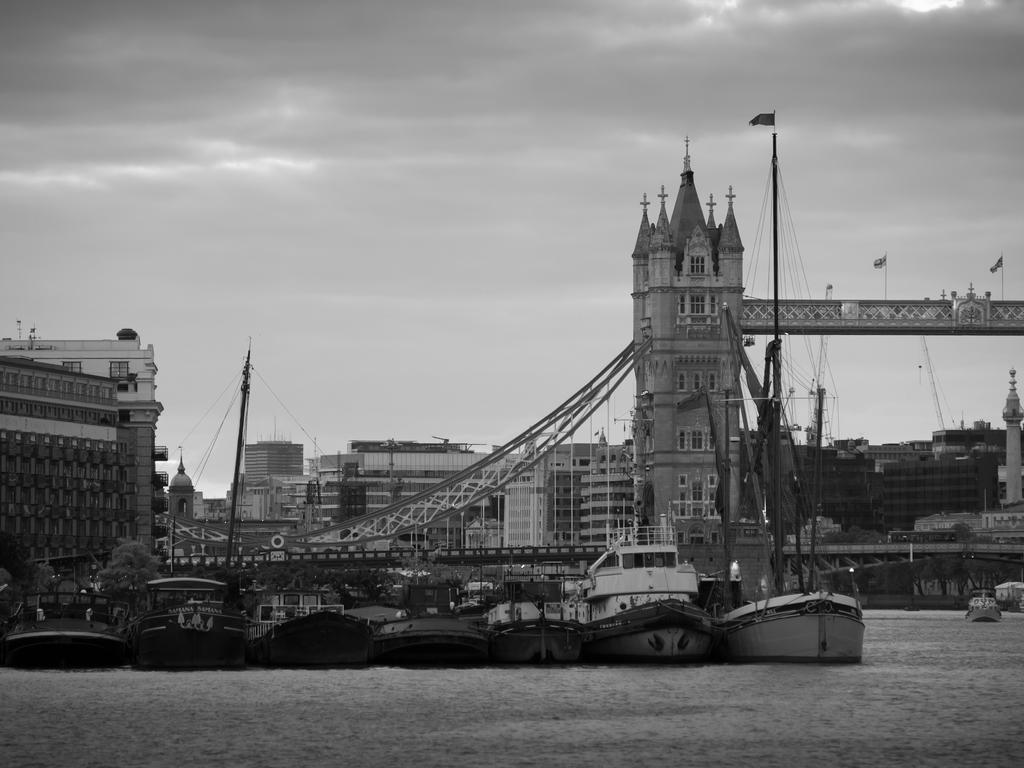What is the color scheme of the image? The image is black and white. What can be seen on the water in the image? There are boats on the water in the image. What structures are present in the image? There are buildings in the image. What objects can be seen in the image that are related to infrastructure? There are poles and wires in the image. What additional elements can be seen in the image? There are flags in the image. What is visible in the background of the image? The sky is visible in the background of the image. What type of wave can be seen crashing against the boats in the image? There are no waves visible in the image; it is a black and white image with boats on the water. What effect does the wave have on the boats in the image? Since there are no waves in the image, there is no effect on the boats. 